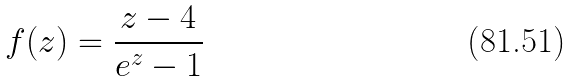<formula> <loc_0><loc_0><loc_500><loc_500>f ( z ) = \frac { z - 4 } { e ^ { z } - 1 }</formula> 